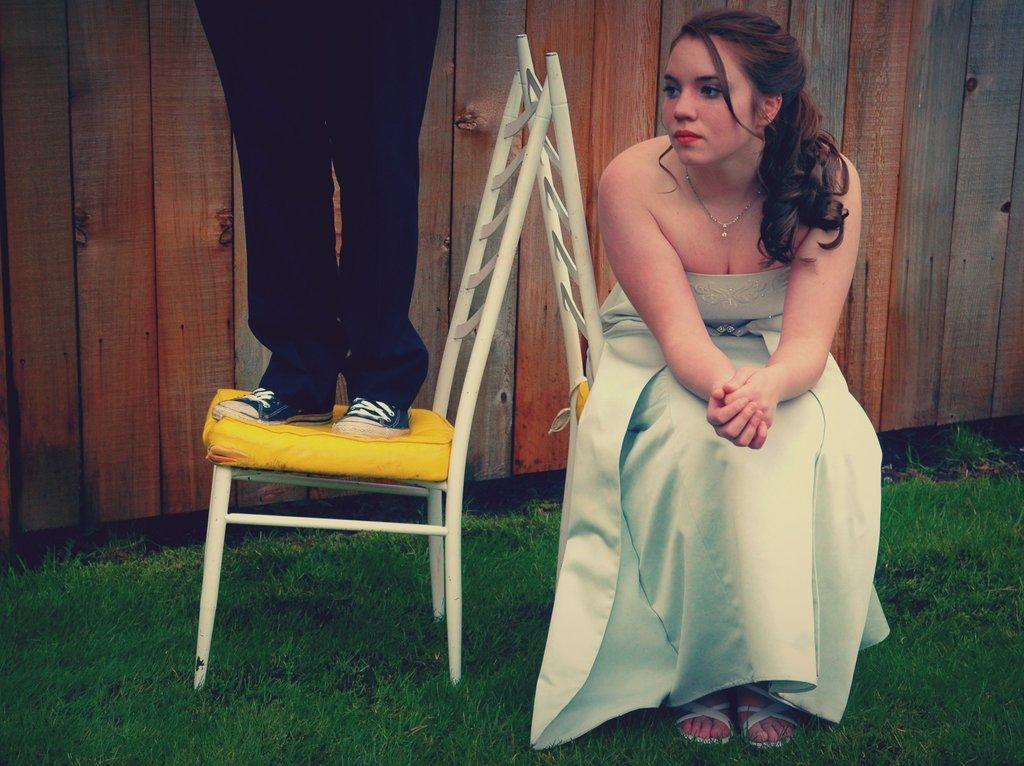What is the woman in the image doing? The woman is sitting in a chair. What is the other person doing in the image? The other person is standing on a chair beside her. What can be seen on the ground in the image? The ground is covered in greenery. What type of roll can be seen being played by the woman in the image? There is no roll or any indication of a game being played in the image. 